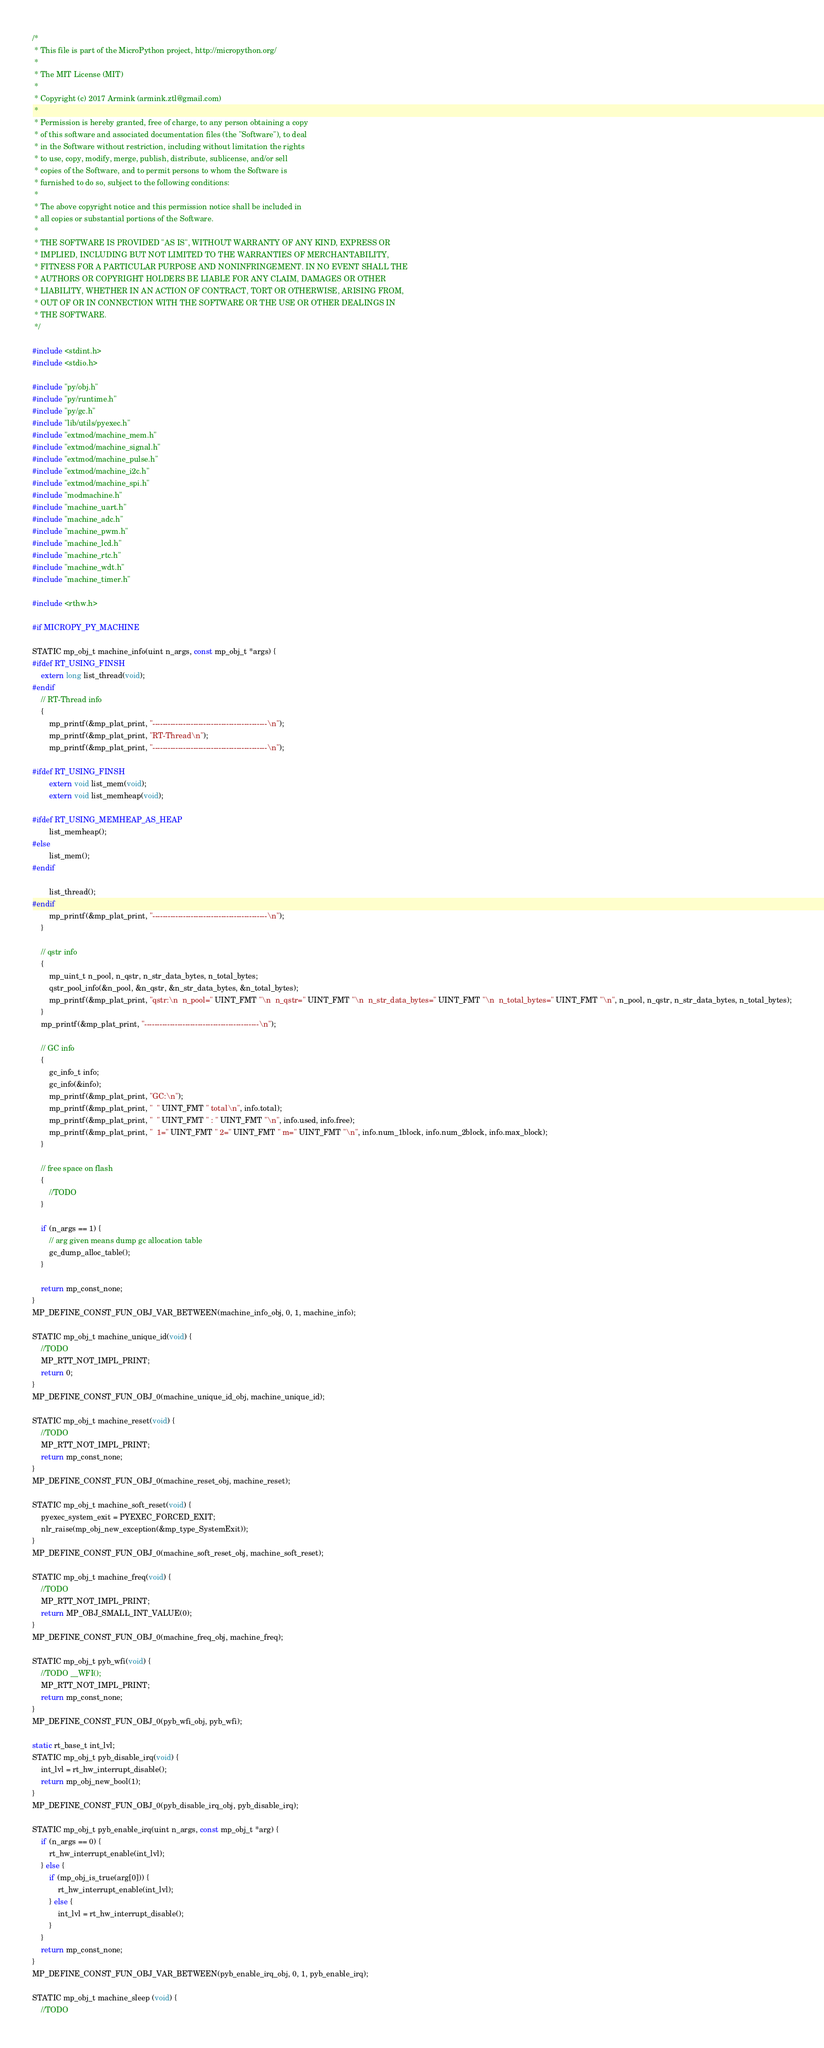Convert code to text. <code><loc_0><loc_0><loc_500><loc_500><_C_>/*
 * This file is part of the MicroPython project, http://micropython.org/
 *
 * The MIT License (MIT)
 *
 * Copyright (c) 2017 Armink (armink.ztl@gmail.com)
 *
 * Permission is hereby granted, free of charge, to any person obtaining a copy
 * of this software and associated documentation files (the "Software"), to deal
 * in the Software without restriction, including without limitation the rights
 * to use, copy, modify, merge, publish, distribute, sublicense, and/or sell
 * copies of the Software, and to permit persons to whom the Software is
 * furnished to do so, subject to the following conditions:
 *
 * The above copyright notice and this permission notice shall be included in
 * all copies or substantial portions of the Software.
 *
 * THE SOFTWARE IS PROVIDED "AS IS", WITHOUT WARRANTY OF ANY KIND, EXPRESS OR
 * IMPLIED, INCLUDING BUT NOT LIMITED TO THE WARRANTIES OF MERCHANTABILITY,
 * FITNESS FOR A PARTICULAR PURPOSE AND NONINFRINGEMENT. IN NO EVENT SHALL THE
 * AUTHORS OR COPYRIGHT HOLDERS BE LIABLE FOR ANY CLAIM, DAMAGES OR OTHER
 * LIABILITY, WHETHER IN AN ACTION OF CONTRACT, TORT OR OTHERWISE, ARISING FROM,
 * OUT OF OR IN CONNECTION WITH THE SOFTWARE OR THE USE OR OTHER DEALINGS IN
 * THE SOFTWARE.
 */

#include <stdint.h>
#include <stdio.h>

#include "py/obj.h"
#include "py/runtime.h"
#include "py/gc.h"
#include "lib/utils/pyexec.h"
#include "extmod/machine_mem.h"
#include "extmod/machine_signal.h"
#include "extmod/machine_pulse.h"
#include "extmod/machine_i2c.h"
#include "extmod/machine_spi.h"
#include "modmachine.h"
#include "machine_uart.h"
#include "machine_adc.h"
#include "machine_pwm.h"
#include "machine_lcd.h"
#include "machine_rtc.h"
#include "machine_wdt.h"
#include "machine_timer.h"

#include <rthw.h>

#if MICROPY_PY_MACHINE

STATIC mp_obj_t machine_info(uint n_args, const mp_obj_t *args) {
#ifdef RT_USING_FINSH
    extern long list_thread(void);
#endif
    // RT-Thread info
    {
        mp_printf(&mp_plat_print, "---------------------------------------------\n");
        mp_printf(&mp_plat_print, "RT-Thread\n");
        mp_printf(&mp_plat_print, "---------------------------------------------\n");

#ifdef RT_USING_FINSH
        extern void list_mem(void);
        extern void list_memheap(void);

#ifdef RT_USING_MEMHEAP_AS_HEAP
        list_memheap();
#else
        list_mem();
#endif

        list_thread();
#endif
        mp_printf(&mp_plat_print, "---------------------------------------------\n");
    }

    // qstr info
    {
        mp_uint_t n_pool, n_qstr, n_str_data_bytes, n_total_bytes;
        qstr_pool_info(&n_pool, &n_qstr, &n_str_data_bytes, &n_total_bytes);
        mp_printf(&mp_plat_print, "qstr:\n  n_pool=" UINT_FMT "\n  n_qstr=" UINT_FMT "\n  n_str_data_bytes=" UINT_FMT "\n  n_total_bytes=" UINT_FMT "\n", n_pool, n_qstr, n_str_data_bytes, n_total_bytes);
    }
    mp_printf(&mp_plat_print, "---------------------------------------------\n");

    // GC info
    {
        gc_info_t info;
        gc_info(&info);
        mp_printf(&mp_plat_print, "GC:\n");
        mp_printf(&mp_plat_print, "  " UINT_FMT " total\n", info.total);
        mp_printf(&mp_plat_print, "  " UINT_FMT " : " UINT_FMT "\n", info.used, info.free);
        mp_printf(&mp_plat_print, "  1=" UINT_FMT " 2=" UINT_FMT " m=" UINT_FMT "\n", info.num_1block, info.num_2block, info.max_block);
    }

    // free space on flash
    {
        //TODO
    }

    if (n_args == 1) {
        // arg given means dump gc allocation table
        gc_dump_alloc_table();
    }

    return mp_const_none;
}
MP_DEFINE_CONST_FUN_OBJ_VAR_BETWEEN(machine_info_obj, 0, 1, machine_info);

STATIC mp_obj_t machine_unique_id(void) {
    //TODO
    MP_RTT_NOT_IMPL_PRINT;
    return 0;
}
MP_DEFINE_CONST_FUN_OBJ_0(machine_unique_id_obj, machine_unique_id);

STATIC mp_obj_t machine_reset(void) {
    //TODO
    MP_RTT_NOT_IMPL_PRINT;
    return mp_const_none;
}
MP_DEFINE_CONST_FUN_OBJ_0(machine_reset_obj, machine_reset);

STATIC mp_obj_t machine_soft_reset(void) {
    pyexec_system_exit = PYEXEC_FORCED_EXIT;
    nlr_raise(mp_obj_new_exception(&mp_type_SystemExit));
}
MP_DEFINE_CONST_FUN_OBJ_0(machine_soft_reset_obj, machine_soft_reset);

STATIC mp_obj_t machine_freq(void) {
    //TODO
    MP_RTT_NOT_IMPL_PRINT;
    return MP_OBJ_SMALL_INT_VALUE(0);
}
MP_DEFINE_CONST_FUN_OBJ_0(machine_freq_obj, machine_freq);

STATIC mp_obj_t pyb_wfi(void) {
    //TODO __WFI();
    MP_RTT_NOT_IMPL_PRINT;
    return mp_const_none;
}
MP_DEFINE_CONST_FUN_OBJ_0(pyb_wfi_obj, pyb_wfi);

static rt_base_t int_lvl;
STATIC mp_obj_t pyb_disable_irq(void) {
    int_lvl = rt_hw_interrupt_disable();
    return mp_obj_new_bool(1);
}
MP_DEFINE_CONST_FUN_OBJ_0(pyb_disable_irq_obj, pyb_disable_irq);

STATIC mp_obj_t pyb_enable_irq(uint n_args, const mp_obj_t *arg) {
    if (n_args == 0) {
        rt_hw_interrupt_enable(int_lvl);
    } else {
        if (mp_obj_is_true(arg[0])) {
            rt_hw_interrupt_enable(int_lvl);
        } else {
            int_lvl = rt_hw_interrupt_disable();
        }
    }
    return mp_const_none;
}
MP_DEFINE_CONST_FUN_OBJ_VAR_BETWEEN(pyb_enable_irq_obj, 0, 1, pyb_enable_irq);

STATIC mp_obj_t machine_sleep (void) {
    //TODO</code> 